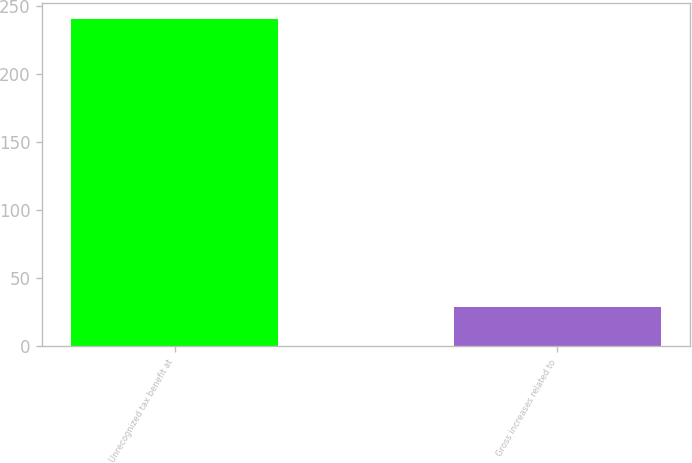Convert chart. <chart><loc_0><loc_0><loc_500><loc_500><bar_chart><fcel>Unrecognized tax benefit at<fcel>Gross increases related to<nl><fcel>240<fcel>29<nl></chart> 